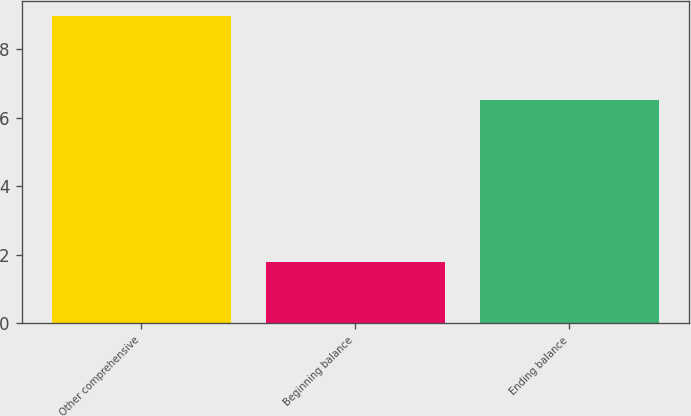<chart> <loc_0><loc_0><loc_500><loc_500><bar_chart><fcel>Other comprehensive<fcel>Beginning balance<fcel>Ending balance<nl><fcel>8.95<fcel>1.8<fcel>6.5<nl></chart> 